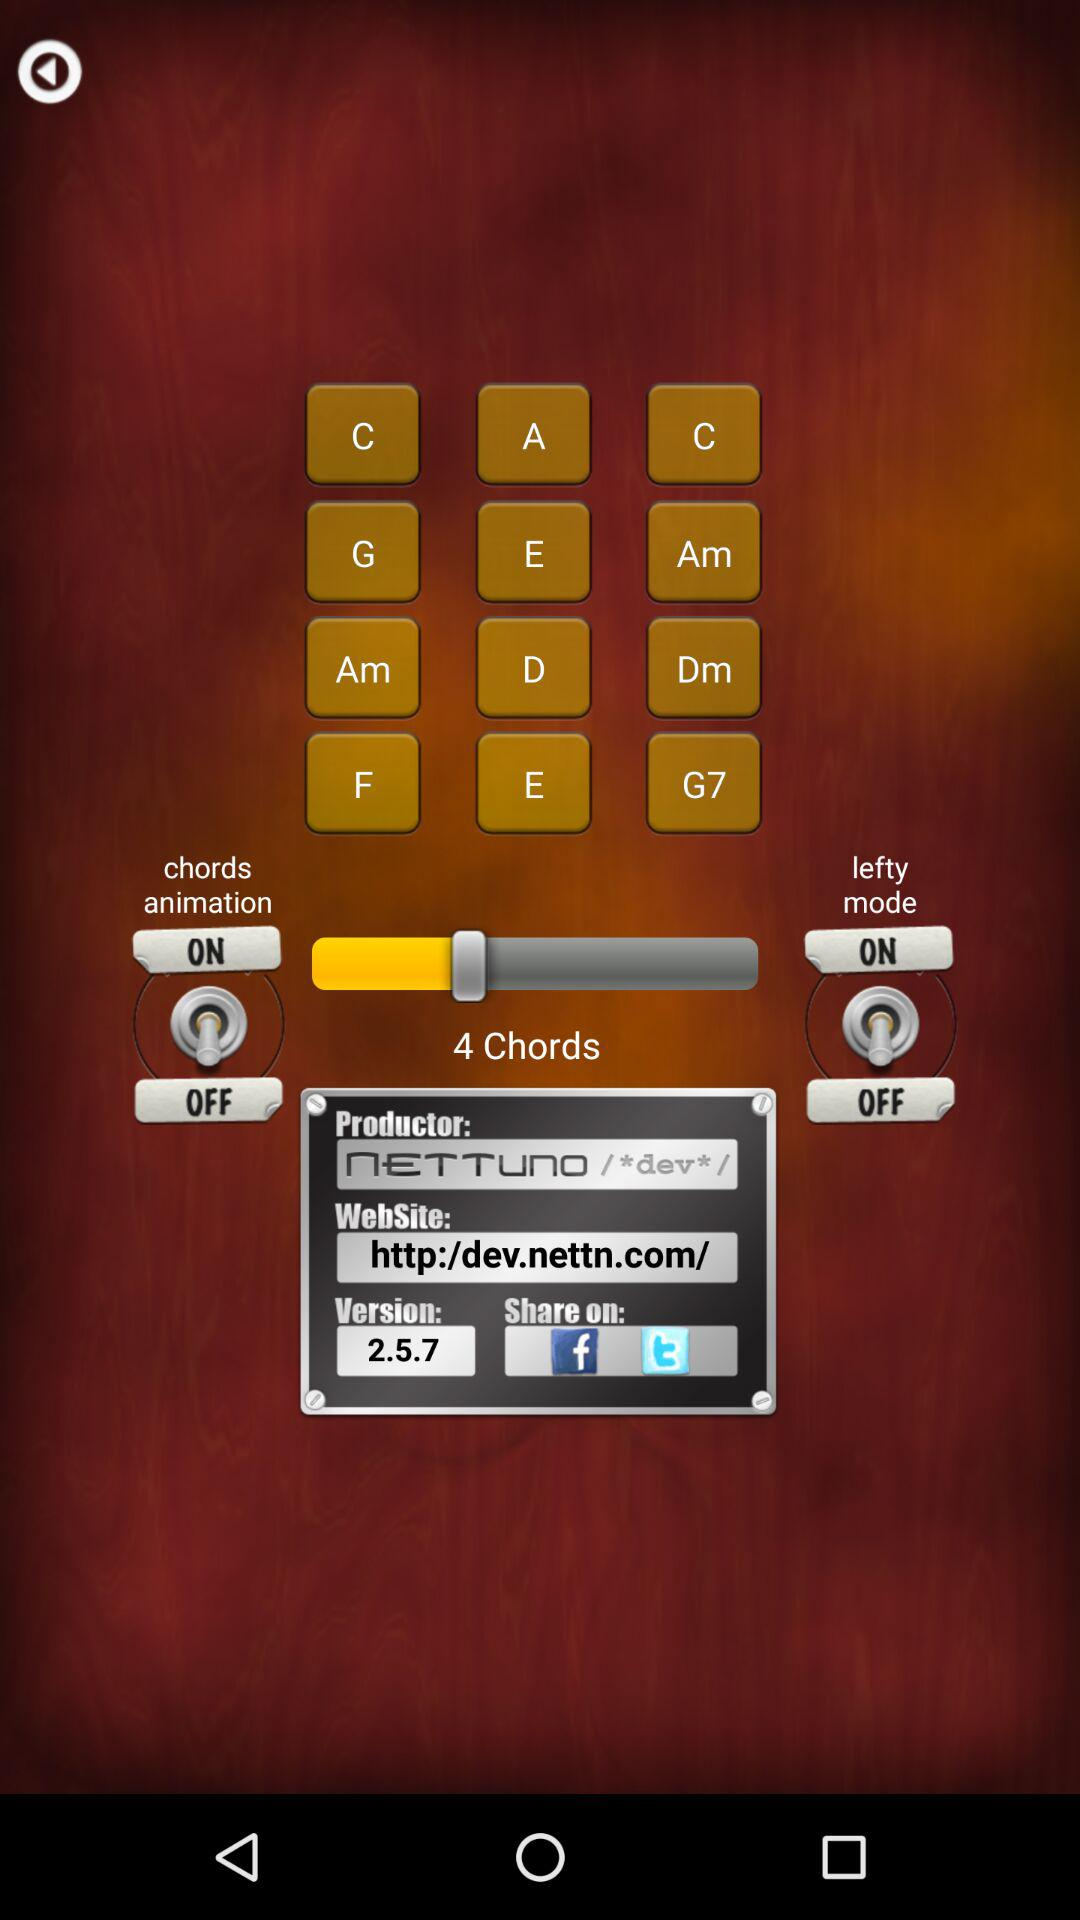What is the website link? The website link is http:/dev.nettn.com/. 